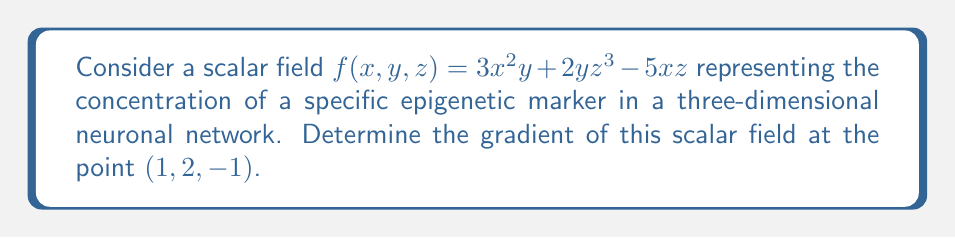Give your solution to this math problem. To find the gradient of a scalar field in three-dimensional space, we need to calculate the partial derivatives with respect to x, y, and z. The gradient is then expressed as a vector of these partial derivatives.

1. Calculate $\frac{\partial f}{\partial x}$:
   $\frac{\partial f}{\partial x} = 6xy - 5z$

2. Calculate $\frac{\partial f}{\partial y}$:
   $\frac{\partial f}{\partial y} = 3x^2 + 2z^3$

3. Calculate $\frac{\partial f}{\partial z}$:
   $\frac{\partial f}{\partial z} = 6yz^2 - 5x$

4. The gradient is given by:
   $$\nabla f = \left(\frac{\partial f}{\partial x}, \frac{\partial f}{\partial y}, \frac{\partial f}{\partial z}\right)$$

5. Substitute the point $(1, 2, -1)$ into each partial derivative:
   $\frac{\partial f}{\partial x}|_{(1,2,-1)} = 6(1)(2) - 5(-1) = 17$
   $\frac{\partial f}{\partial y}|_{(1,2,-1)} = 3(1)^2 + 2(-1)^3 = 1$
   $\frac{\partial f}{\partial z}|_{(1,2,-1)} = 6(2)(-1)^2 - 5(1) = 7$

6. Combine the results into the gradient vector:
   $$\nabla f|_{(1,2,-1)} = (17, 1, 7)$$
Answer: $(17, 1, 7)$ 